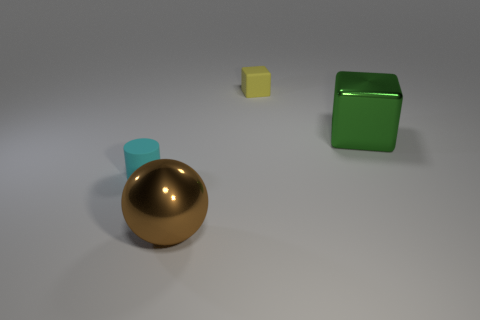Add 4 big cyan metal spheres. How many objects exist? 8 Subtract all cylinders. How many objects are left? 3 Subtract all small gray spheres. Subtract all green metal things. How many objects are left? 3 Add 1 green blocks. How many green blocks are left? 2 Add 2 tiny rubber cubes. How many tiny rubber cubes exist? 3 Subtract 0 purple spheres. How many objects are left? 4 